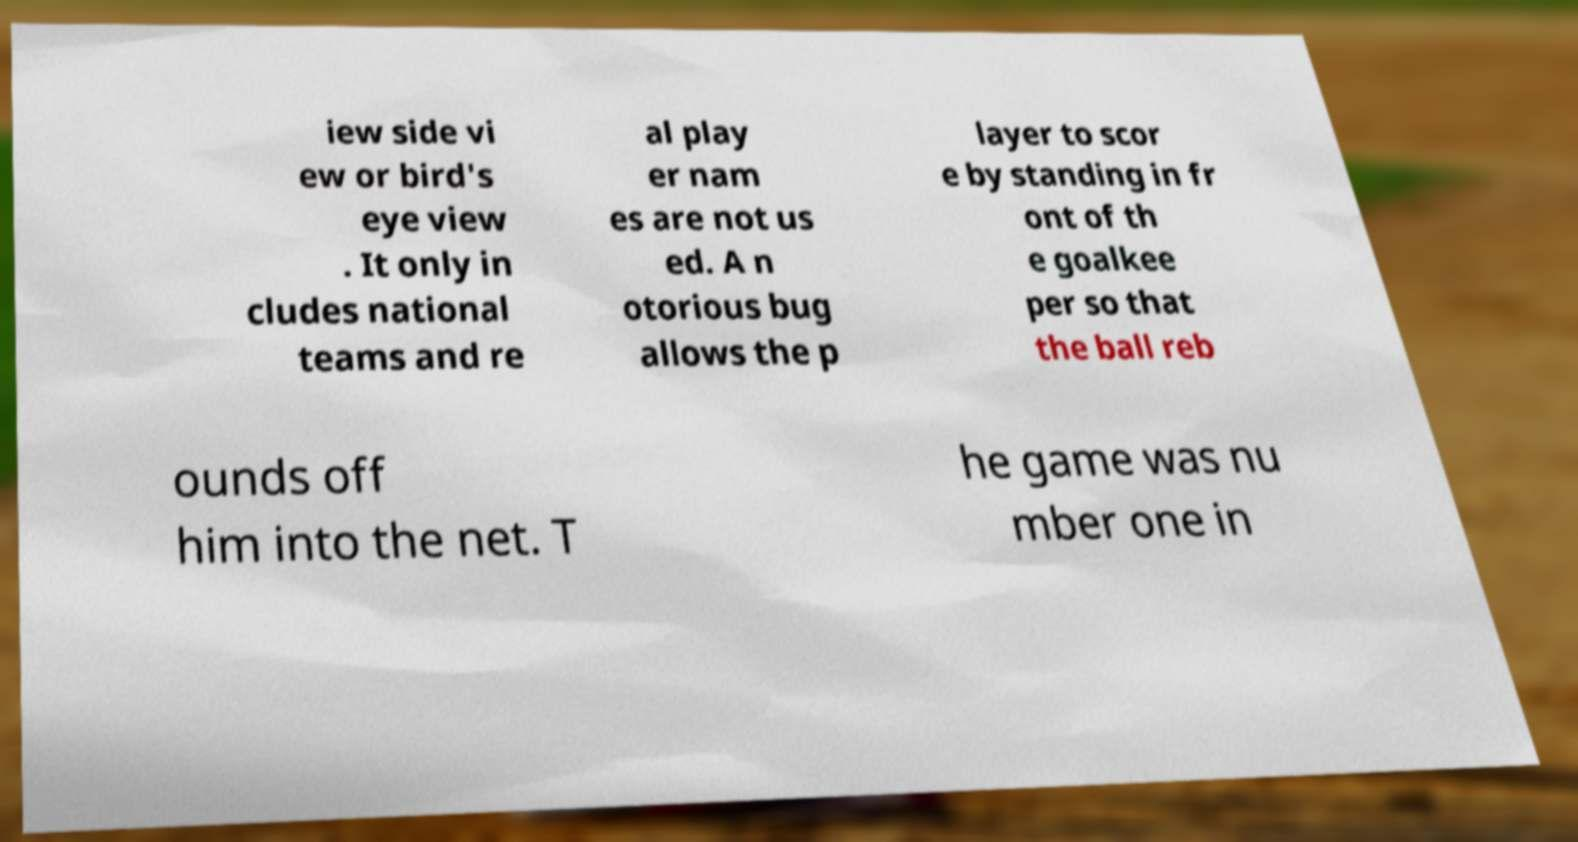Could you extract and type out the text from this image? iew side vi ew or bird's eye view . It only in cludes national teams and re al play er nam es are not us ed. A n otorious bug allows the p layer to scor e by standing in fr ont of th e goalkee per so that the ball reb ounds off him into the net. T he game was nu mber one in 